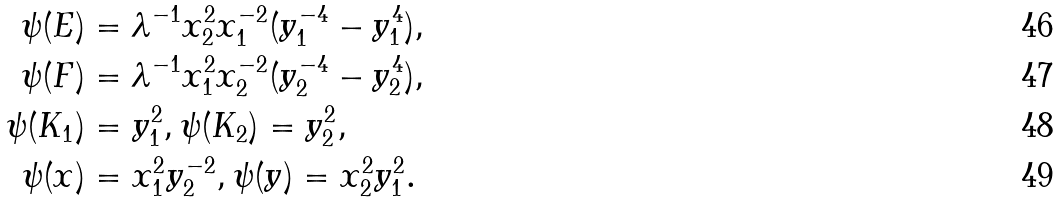<formula> <loc_0><loc_0><loc_500><loc_500>\psi ( E ) & = \lambda ^ { - 1 } x ^ { 2 } _ { 2 } x ^ { - 2 } _ { 1 } ( y ^ { - 4 } _ { 1 } - y ^ { 4 } _ { 1 } ) , \\ \psi ( F ) & = \lambda ^ { - 1 } x ^ { 2 } _ { 1 } x ^ { - 2 } _ { 2 } ( y ^ { - 4 } _ { 2 } - y ^ { 4 } _ { 2 } ) , \\ \psi ( K _ { 1 } ) & = y _ { 1 } ^ { 2 } , \psi ( K _ { 2 } ) = y _ { 2 } ^ { 2 } , \\ \psi ( x ) & = x ^ { 2 } _ { 1 } y ^ { - 2 } _ { 2 } , \psi ( y ) = x _ { 2 } ^ { 2 } y ^ { 2 } _ { 1 } .</formula> 